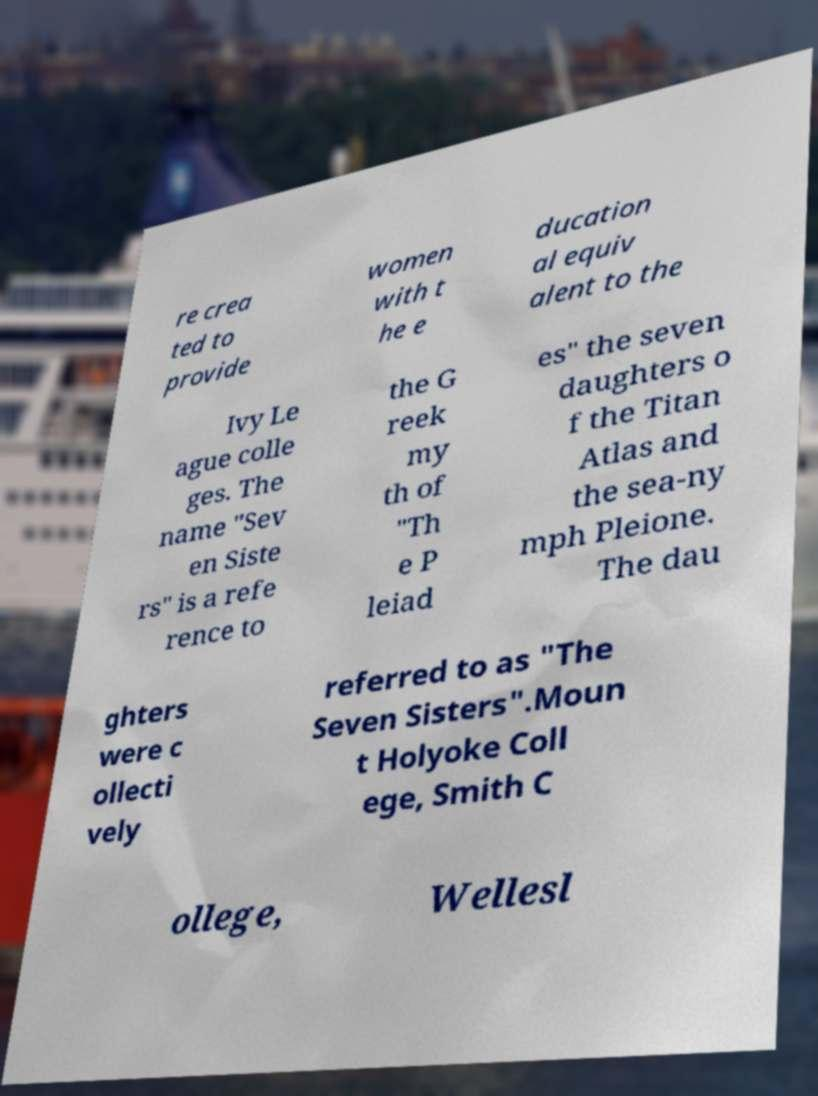What messages or text are displayed in this image? I need them in a readable, typed format. re crea ted to provide women with t he e ducation al equiv alent to the Ivy Le ague colle ges. The name "Sev en Siste rs" is a refe rence to the G reek my th of "Th e P leiad es" the seven daughters o f the Titan Atlas and the sea-ny mph Pleione. The dau ghters were c ollecti vely referred to as "The Seven Sisters".Moun t Holyoke Coll ege, Smith C ollege, Wellesl 